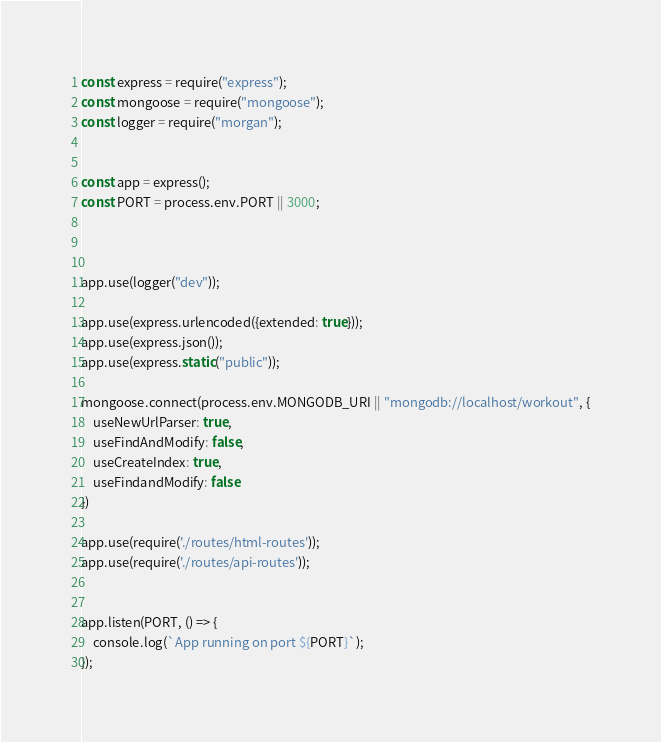<code> <loc_0><loc_0><loc_500><loc_500><_JavaScript_>const express = require("express");
const mongoose = require("mongoose");
const logger = require("morgan");


const app = express();
const PORT = process.env.PORT || 3000;



app.use(logger("dev"));

app.use(express.urlencoded({extended: true}));
app.use(express.json());
app.use(express.static("public"));

mongoose.connect(process.env.MONGODB_URI || "mongodb://localhost/workout", {
    useNewUrlParser: true,
    useFindAndModify: false,
    useCreateIndex: true,
    useFindandModify: false
})

app.use(require('./routes/html-routes'));
app.use(require('./routes/api-routes'));


app.listen(PORT, () => {
    console.log(`App running on port ${PORT}`);
});</code> 